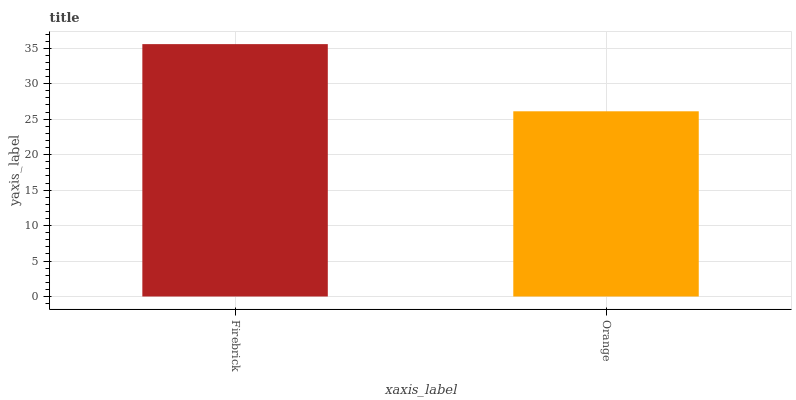Is Orange the minimum?
Answer yes or no. Yes. Is Firebrick the maximum?
Answer yes or no. Yes. Is Orange the maximum?
Answer yes or no. No. Is Firebrick greater than Orange?
Answer yes or no. Yes. Is Orange less than Firebrick?
Answer yes or no. Yes. Is Orange greater than Firebrick?
Answer yes or no. No. Is Firebrick less than Orange?
Answer yes or no. No. Is Firebrick the high median?
Answer yes or no. Yes. Is Orange the low median?
Answer yes or no. Yes. Is Orange the high median?
Answer yes or no. No. Is Firebrick the low median?
Answer yes or no. No. 